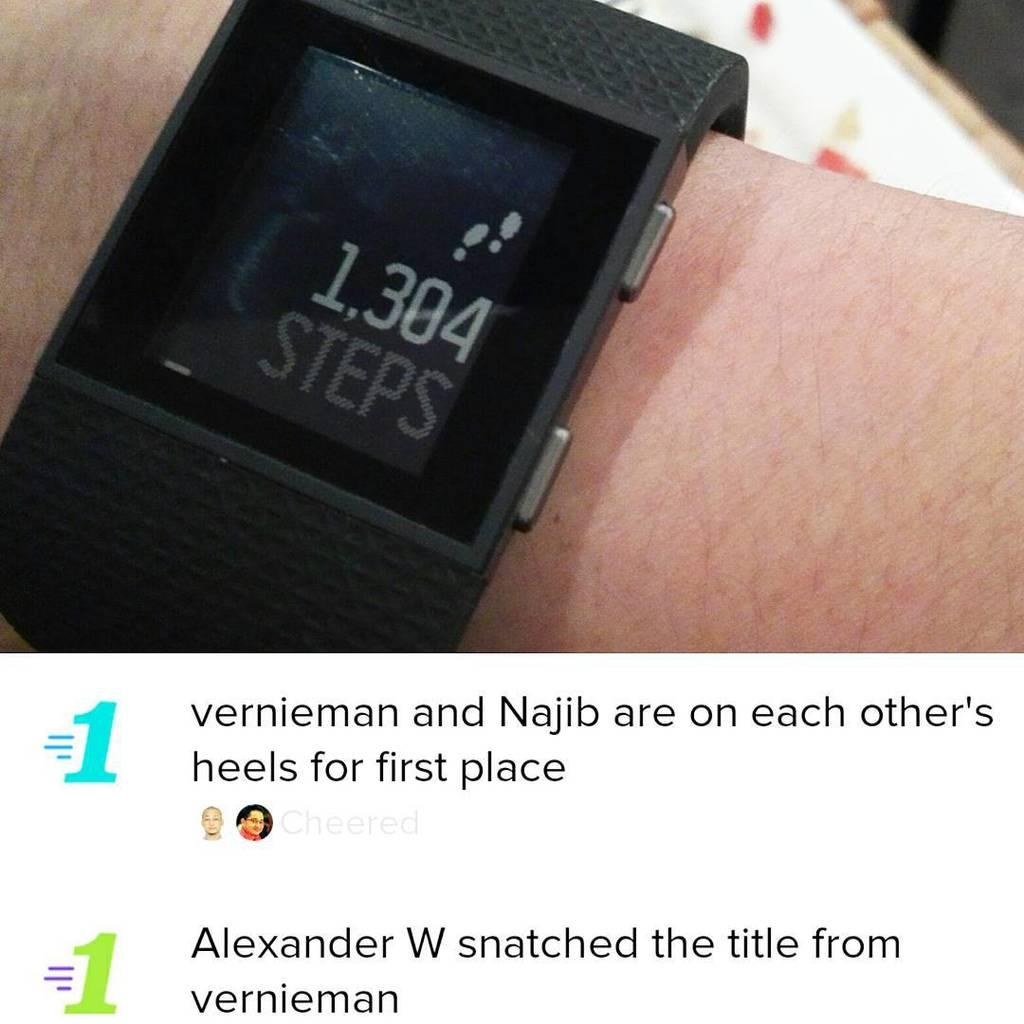Provide a one-sentence caption for the provided image. The fitness watch reads that person has taken 1304 steps. 